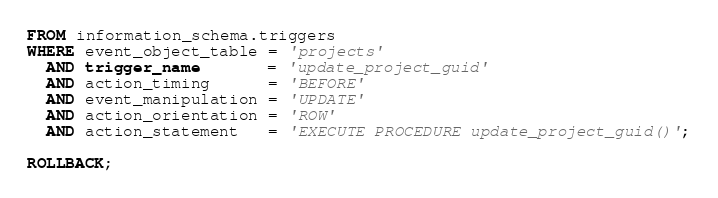Convert code to text. <code><loc_0><loc_0><loc_500><loc_500><_SQL_>FROM information_schema.triggers
WHERE event_object_table = 'projects'
  AND trigger_name       = 'update_project_guid'
  AND action_timing      = 'BEFORE'
  AND event_manipulation = 'UPDATE'
  AND action_orientation = 'ROW'
  AND action_statement   = 'EXECUTE PROCEDURE update_project_guid()';

ROLLBACK;
</code> 